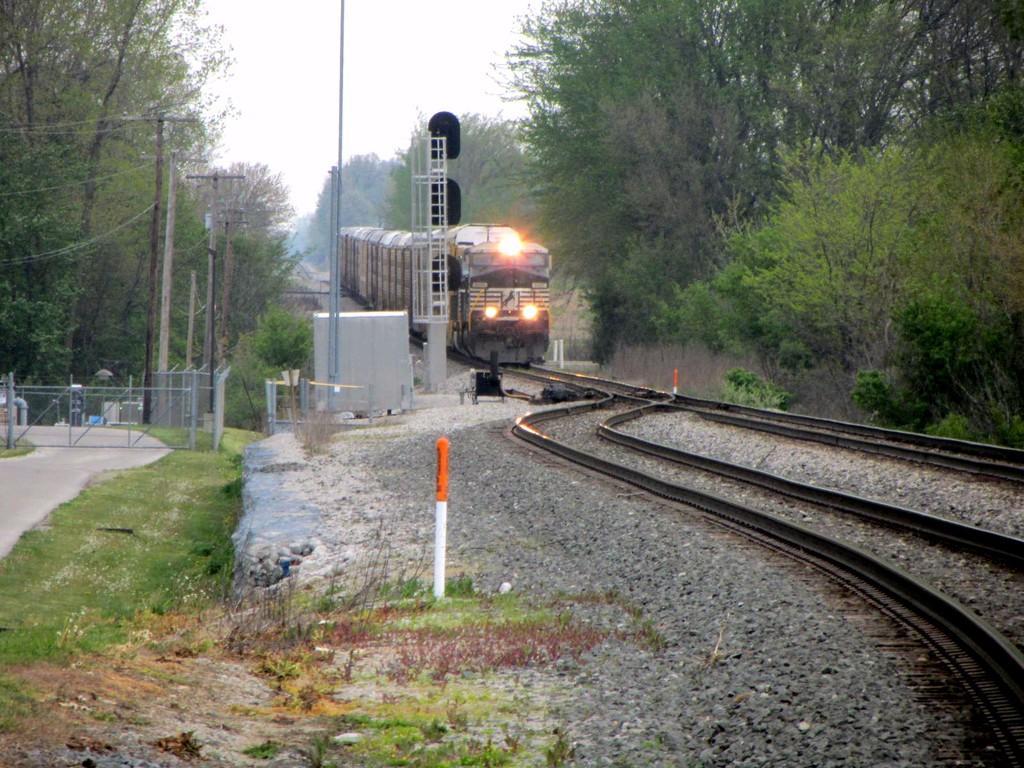Can you describe this image briefly? In this picture we can see a train on the railway track. On the left and right side of the railway tracks, there are lane ropes. On the left side of the image, there are electric poles with cables and there are poles, fencing, grass and a path. On the left and right side of the train, there are trees. At the top of the image, there is the sky. At the bottom of the image, there are stones. 